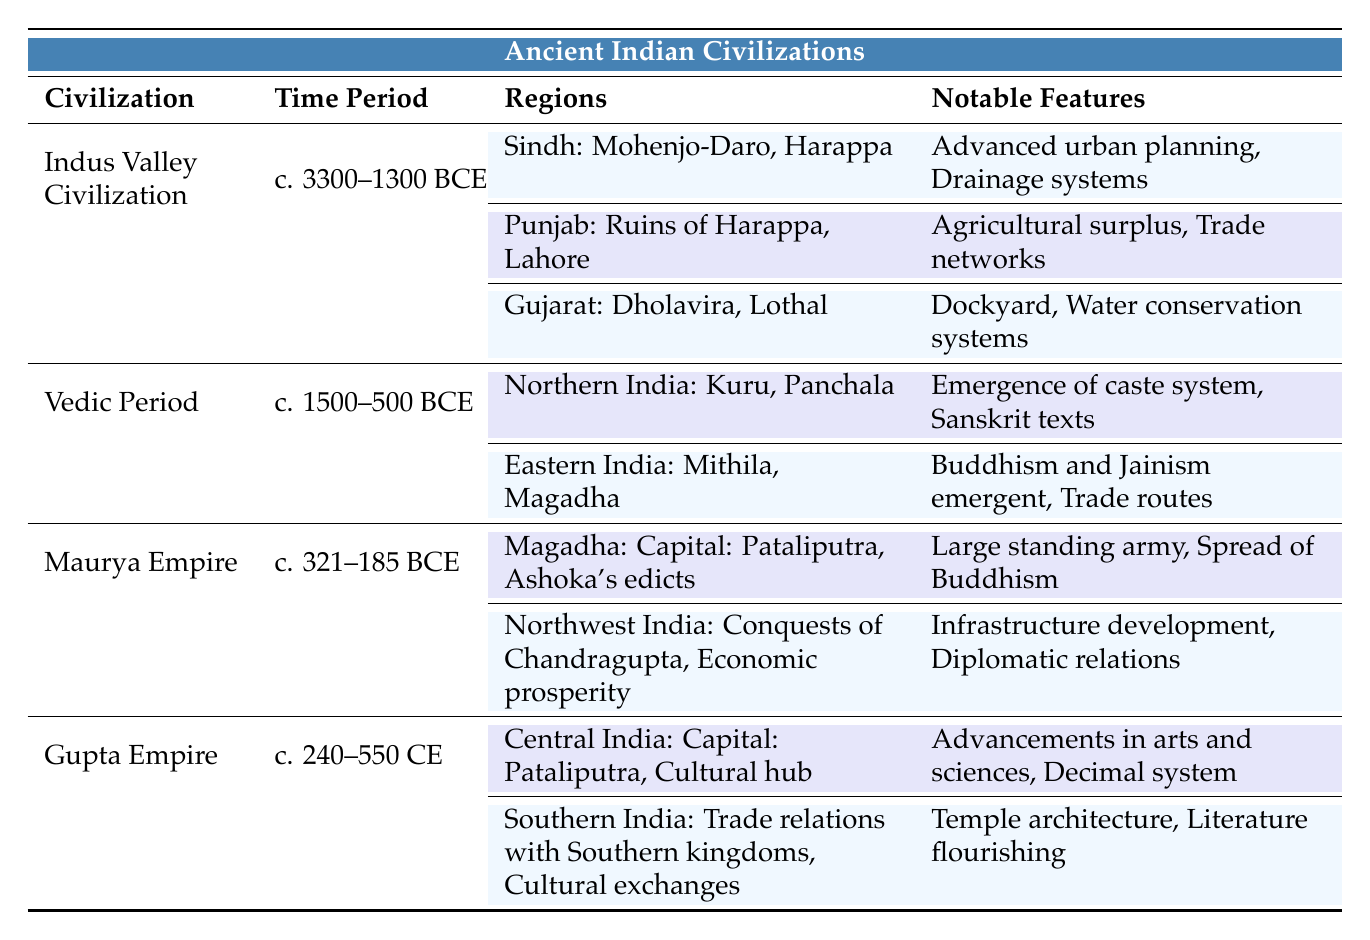What is the time period of the Indus Valley Civilization? The table states that the Indus Valley Civilization existed from c. 3300–1300 BCE. This is directly reflected in the corresponding row for the civilization.
Answer: c. 3300–1300 BCE Which notable feature is associated with the major cities of Sindh in the Indus Valley Civilization? According to the table, the notable features listed for Sindh, which includes Mohenjo-Daro and Harappa, are advanced urban planning and drainage systems.
Answer: Advanced urban planning, drainage systems Are the major kingdoms of Eastern India during the Vedic Period associated with the emergence of Buddhism? Yes, the table indicates that Eastern India had kingdoms like Mithila and Magadha during the Vedic Period, and their notable feature mentions the emergent Buddhism and Jainism.
Answer: Yes Which civilization has notable features related to the decimal system? The table shows that the Gupta Empire, which lasted from c. 240–550 CE, lists advancements in arts and sciences and the decimal system as its notable features.
Answer: Gupta Empire What notable feature distinguishes the Maurya Empire in Magadha compared to its status in Northwest India? The table lists for the Maurya Empire in Magadha that it had a large standing army and spread of Buddhism, while Northwest India highlights economic prosperity and infrastructure development. Thus, the notable feature of Magadha is that it is associated with Ashoka's edicts and military strength compared to Northwest's economic focus.
Answer: Large standing army; spread of Buddhism How many regions are mentioned for the Vedic Period? The table specifies two regions for the Vedic Period: Northern India and Eastern India. This is counted directly from the regions listed under the Vedic Period.
Answer: 2 regions Was the capital of the Gupta Empire the same as that of the Maurya Empire? Yes, both the Gupta and Maurya Empires list Pataliputra as their capital in the table. Therefore, the answer is confirmed by checking the highlights for each civilization.
Answer: Yes What are the major cities of the region Gujarat in the context of the Indus Valley Civilization? The relevant row indicates that the major cities in Gujarat during the Indus Valley Civilization include Dholavira and Lothal. This is directly stated in the table.
Answer: Dholavira, Lothal What is the notable feature common between the Gupta Empire and the Maurya Empire? The table reveals that both the Maurya Empire and the Gupta Empire have notable features related to cultural and infrastructure development (like the spread of Buddhism and advancements in arts/sciences). However, the specific details differ, thus showcasing a common emphasis on development during their respective periods.
Answer: Cultural and infrastructure development 